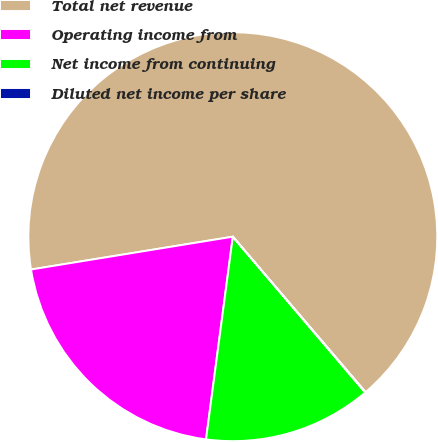Convert chart to OTSL. <chart><loc_0><loc_0><loc_500><loc_500><pie_chart><fcel>Total net revenue<fcel>Operating income from<fcel>Net income from continuing<fcel>Diluted net income per share<nl><fcel>66.31%<fcel>20.34%<fcel>13.3%<fcel>0.04%<nl></chart> 